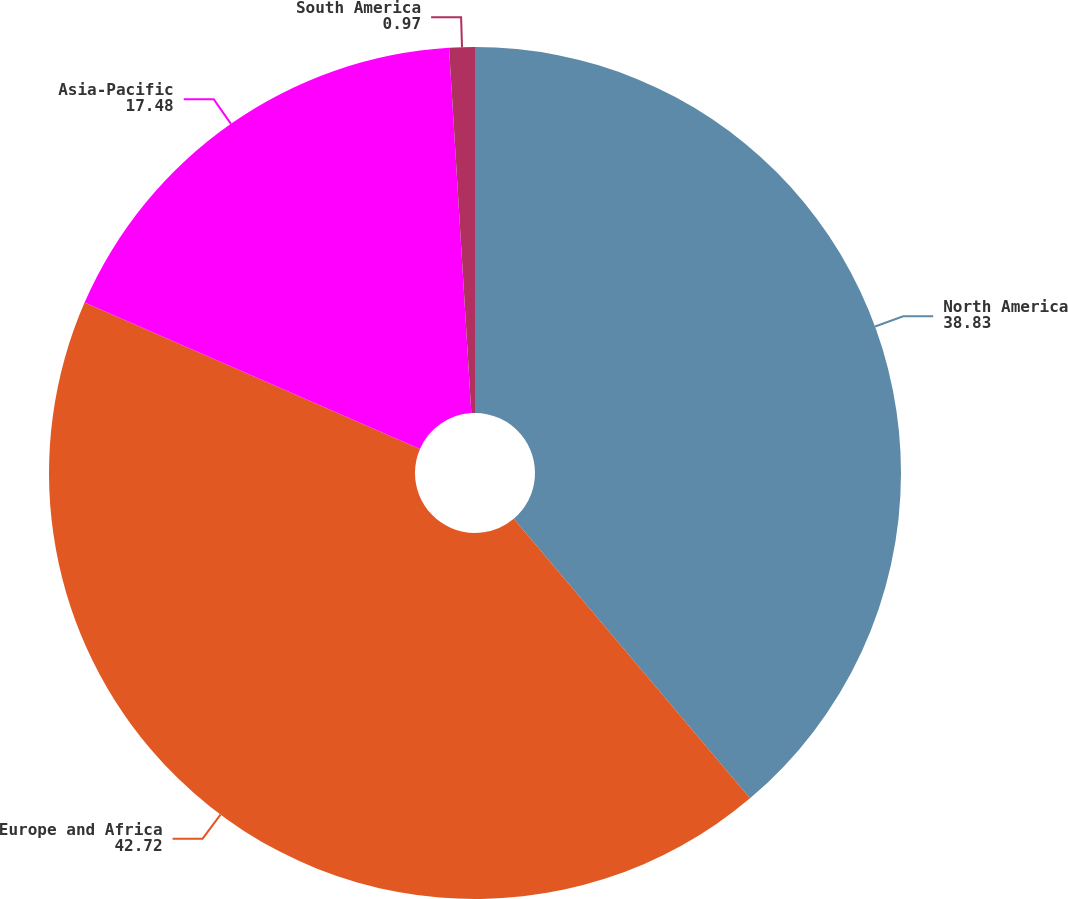Convert chart to OTSL. <chart><loc_0><loc_0><loc_500><loc_500><pie_chart><fcel>North America<fcel>Europe and Africa<fcel>Asia-Pacific<fcel>South America<nl><fcel>38.83%<fcel>42.72%<fcel>17.48%<fcel>0.97%<nl></chart> 